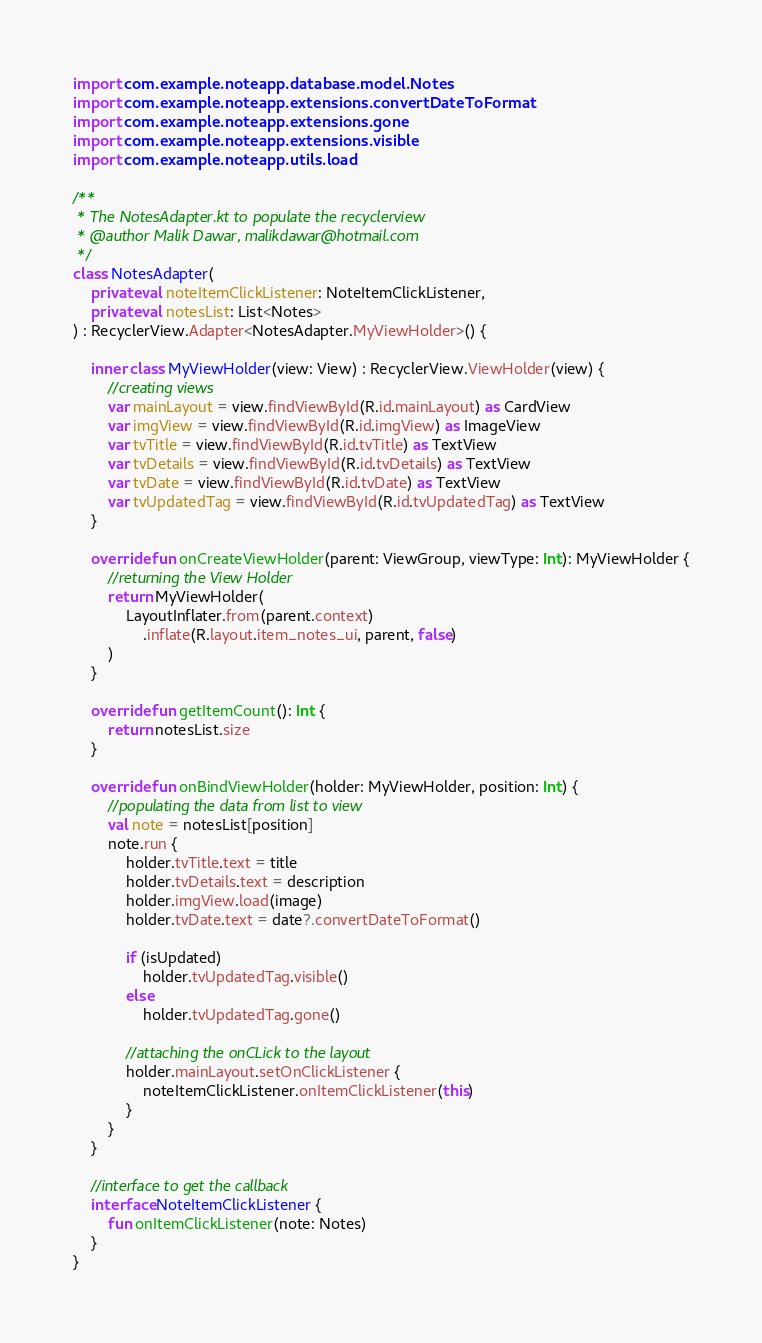<code> <loc_0><loc_0><loc_500><loc_500><_Kotlin_>import com.example.noteapp.database.model.Notes
import com.example.noteapp.extensions.convertDateToFormat
import com.example.noteapp.extensions.gone
import com.example.noteapp.extensions.visible
import com.example.noteapp.utils.load

/**
 * The NotesAdapter.kt to populate the recyclerview
 * @author Malik Dawar, malikdawar@hotmail.com
 */
class NotesAdapter(
    private val noteItemClickListener: NoteItemClickListener,
    private val notesList: List<Notes>
) : RecyclerView.Adapter<NotesAdapter.MyViewHolder>() {

    inner class MyViewHolder(view: View) : RecyclerView.ViewHolder(view) {
        //creating views
        var mainLayout = view.findViewById(R.id.mainLayout) as CardView
        var imgView = view.findViewById(R.id.imgView) as ImageView
        var tvTitle = view.findViewById(R.id.tvTitle) as TextView
        var tvDetails = view.findViewById(R.id.tvDetails) as TextView
        var tvDate = view.findViewById(R.id.tvDate) as TextView
        var tvUpdatedTag = view.findViewById(R.id.tvUpdatedTag) as TextView
    }

    override fun onCreateViewHolder(parent: ViewGroup, viewType: Int): MyViewHolder {
        //returning the View Holder
        return MyViewHolder(
            LayoutInflater.from(parent.context)
                .inflate(R.layout.item_notes_ui, parent, false)
        )
    }

    override fun getItemCount(): Int {
        return notesList.size
    }

    override fun onBindViewHolder(holder: MyViewHolder, position: Int) {
        //populating the data from list to view
        val note = notesList[position]
        note.run {
            holder.tvTitle.text = title
            holder.tvDetails.text = description
            holder.imgView.load(image)
            holder.tvDate.text = date?.convertDateToFormat()

            if (isUpdated)
                holder.tvUpdatedTag.visible()
            else
                holder.tvUpdatedTag.gone()

            //attaching the onCLick to the layout
            holder.mainLayout.setOnClickListener {
                noteItemClickListener.onItemClickListener(this)
            }
        }
    }

    //interface to get the callback
    interface NoteItemClickListener {
        fun onItemClickListener(note: Notes)
    }
}</code> 